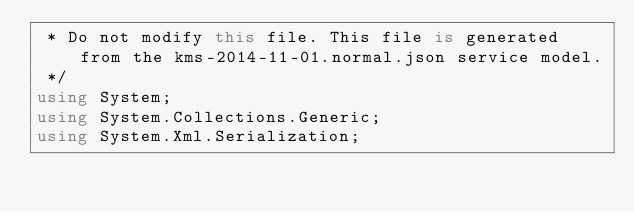<code> <loc_0><loc_0><loc_500><loc_500><_C#_> * Do not modify this file. This file is generated from the kms-2014-11-01.normal.json service model.
 */
using System;
using System.Collections.Generic;
using System.Xml.Serialization;</code> 